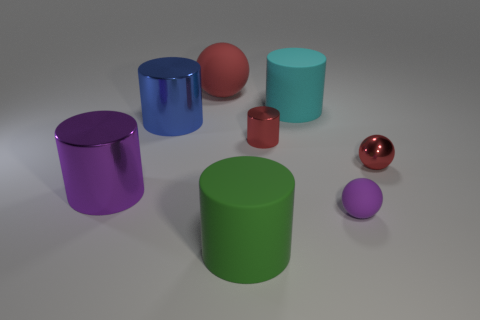What material do the objects seem to be made of? The objects have a smooth and shiny surface, suggesting they could be made of a material like plastic or polished metal, giving them a reflective quality. 